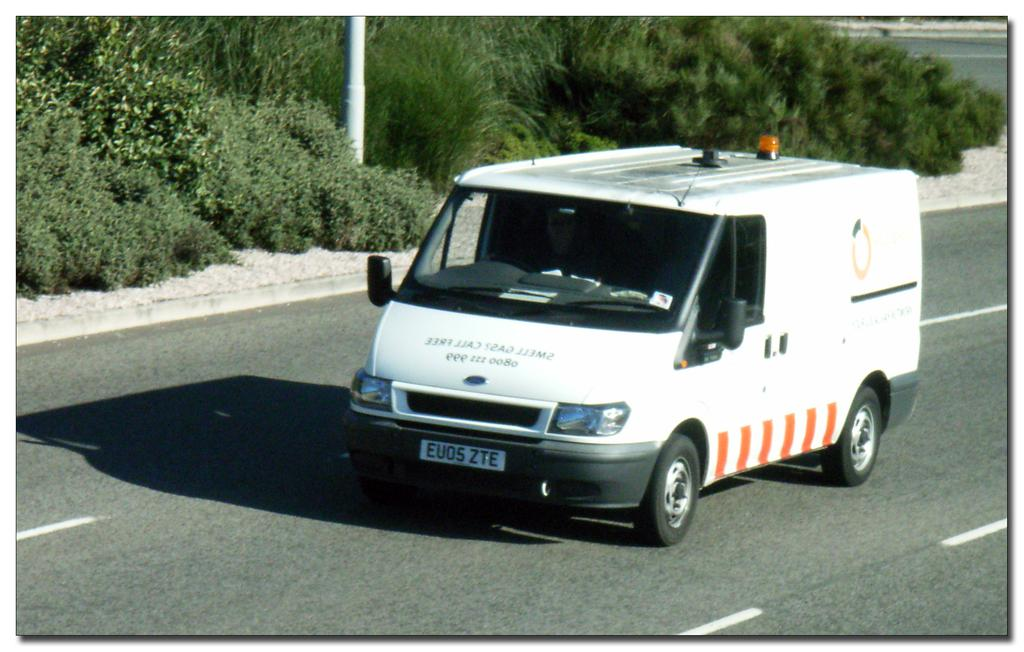<image>
Give a short and clear explanation of the subsequent image. A van has the words "Smell Gas? Call FREE" painted in reverse on the front. 